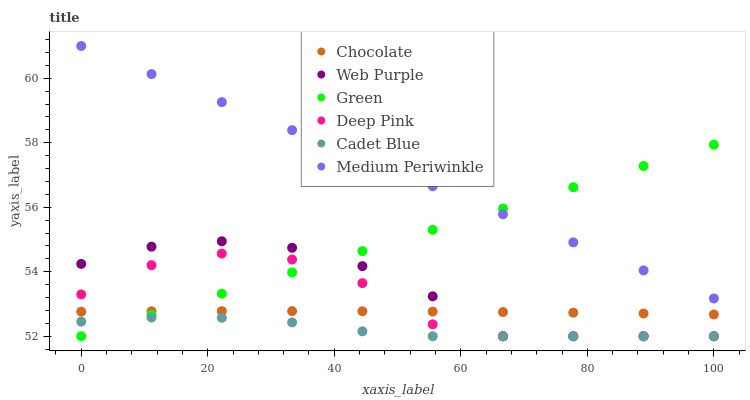Does Cadet Blue have the minimum area under the curve?
Answer yes or no. Yes. Does Medium Periwinkle have the maximum area under the curve?
Answer yes or no. Yes. Does Chocolate have the minimum area under the curve?
Answer yes or no. No. Does Chocolate have the maximum area under the curve?
Answer yes or no. No. Is Green the smoothest?
Answer yes or no. Yes. Is Deep Pink the roughest?
Answer yes or no. Yes. Is Medium Periwinkle the smoothest?
Answer yes or no. No. Is Medium Periwinkle the roughest?
Answer yes or no. No. Does Cadet Blue have the lowest value?
Answer yes or no. Yes. Does Chocolate have the lowest value?
Answer yes or no. No. Does Medium Periwinkle have the highest value?
Answer yes or no. Yes. Does Chocolate have the highest value?
Answer yes or no. No. Is Cadet Blue less than Chocolate?
Answer yes or no. Yes. Is Medium Periwinkle greater than Chocolate?
Answer yes or no. Yes. Does Deep Pink intersect Green?
Answer yes or no. Yes. Is Deep Pink less than Green?
Answer yes or no. No. Is Deep Pink greater than Green?
Answer yes or no. No. Does Cadet Blue intersect Chocolate?
Answer yes or no. No. 